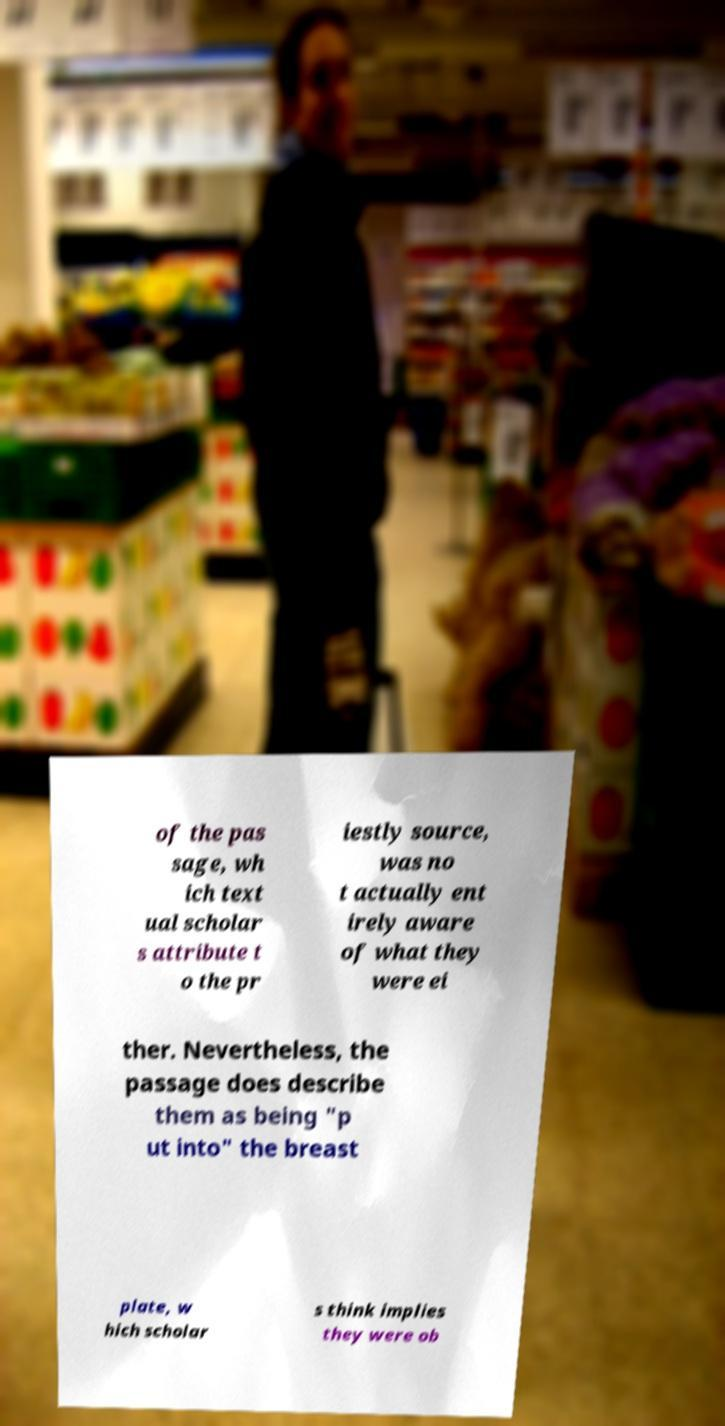I need the written content from this picture converted into text. Can you do that? of the pas sage, wh ich text ual scholar s attribute t o the pr iestly source, was no t actually ent irely aware of what they were ei ther. Nevertheless, the passage does describe them as being "p ut into" the breast plate, w hich scholar s think implies they were ob 